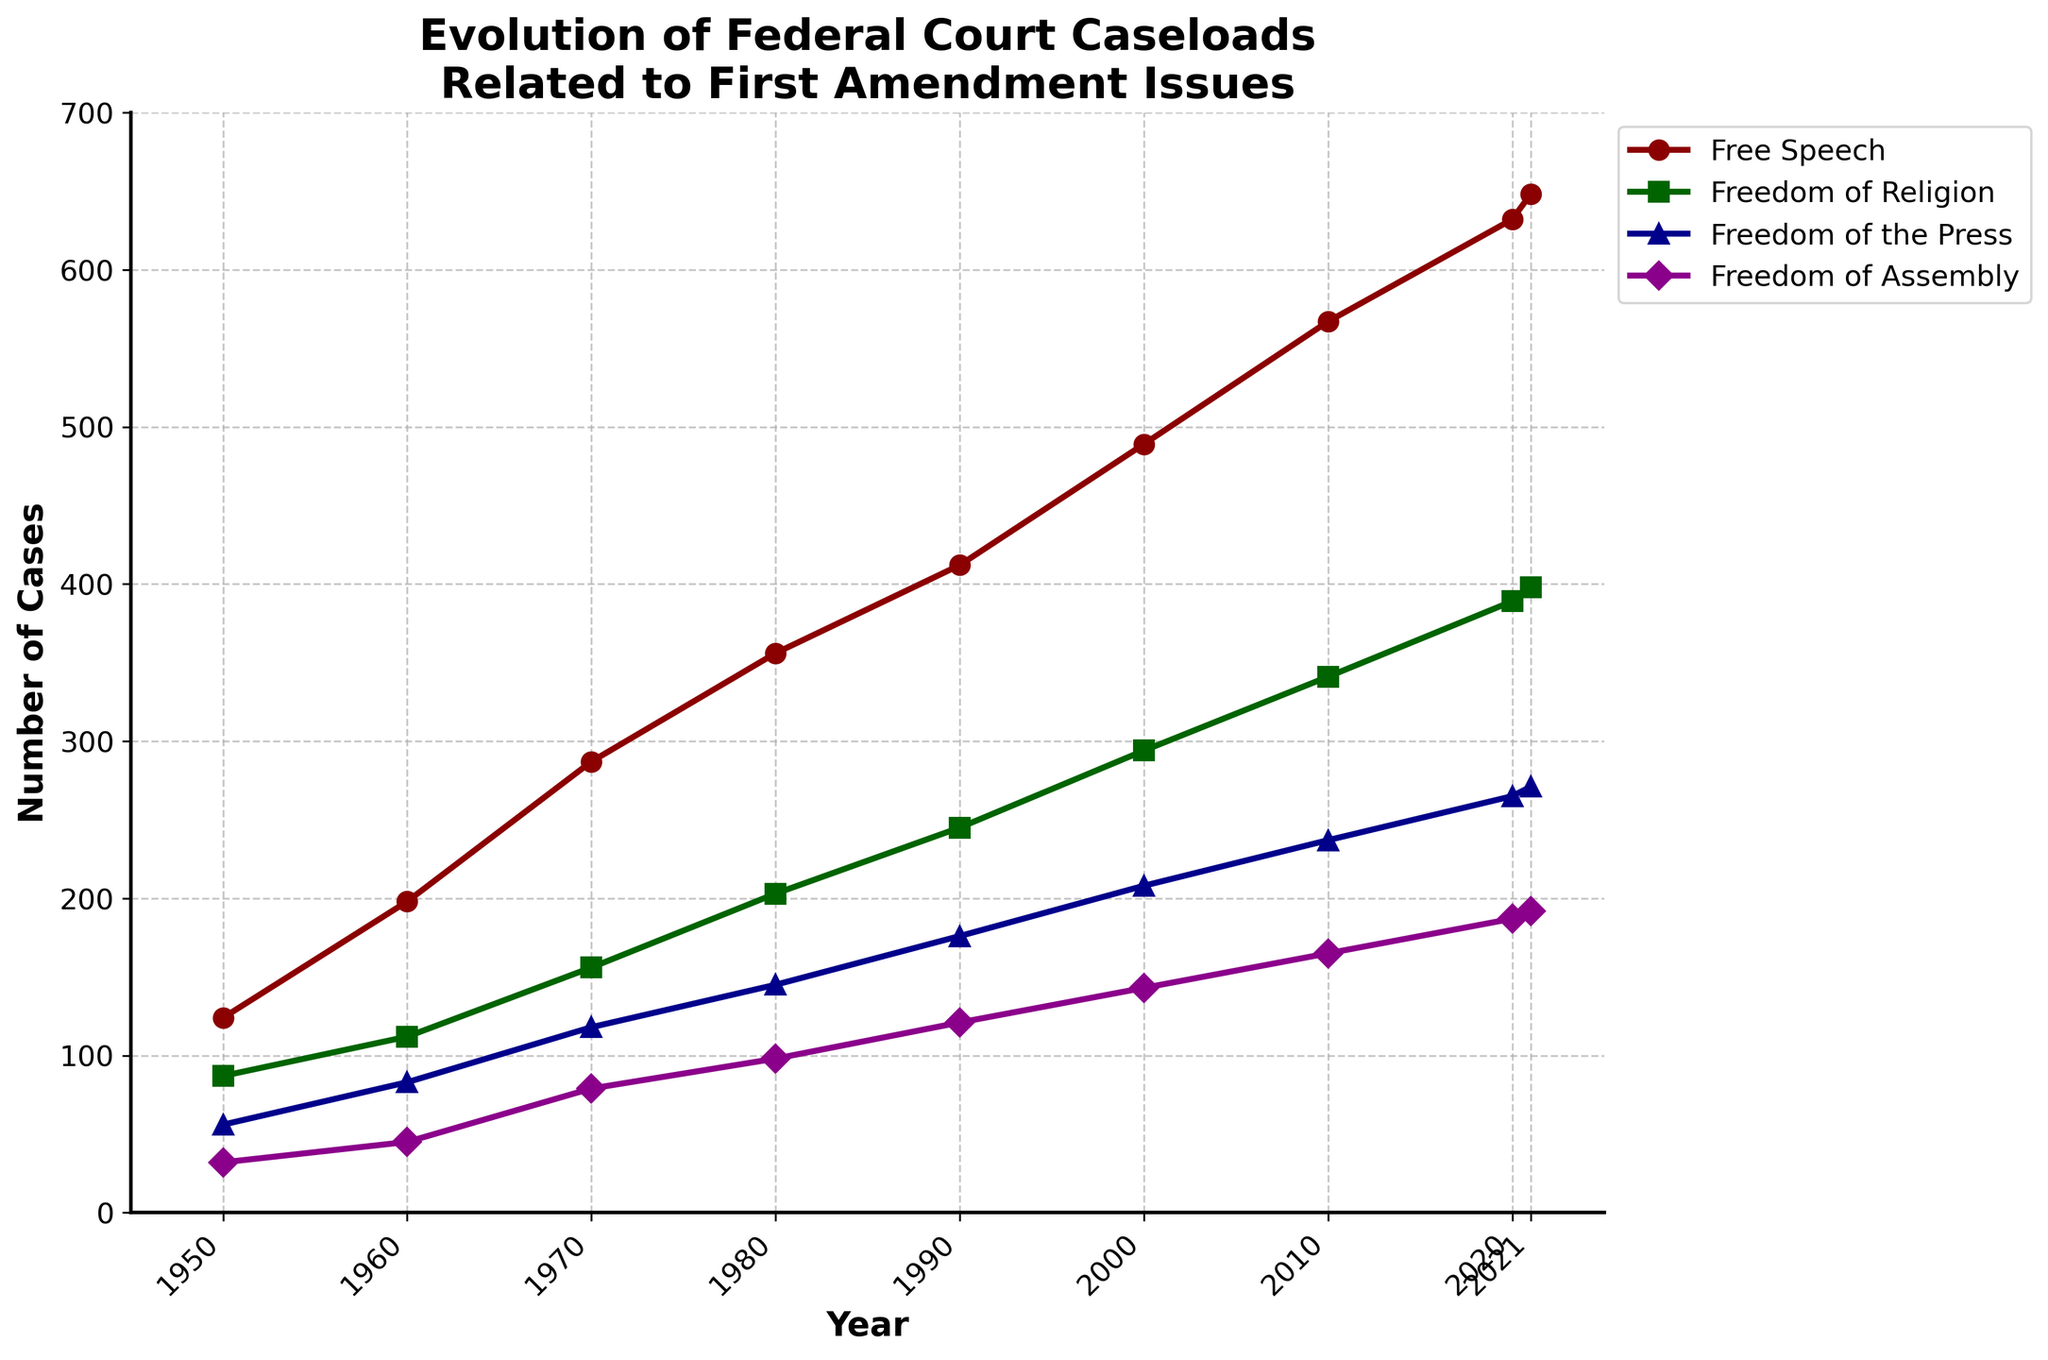1. What is the trend in the number of Free Speech cases from 1950 to 2021? First, observe the line representing Free Speech cases from 1950 to 2021. The line consistently increases, indicating a rising trend in the number of cases over the given years.
Answer: Rising trend 2. By how much did the number of Freedom of the Press cases increase from 1950 to 2021? Check the number of Freedom of the Press cases in 1950 (56) and 2021 (271). Subtract the 1950 value from the 2021 value: 271 - 56 = 215.
Answer: 215 3. Which year had the highest number of Freedom of Religion cases? Identify the peak of the green line representing Freedom of Religion cases. The highest point on the green line is in 2021, with 398 cases.
Answer: 2021 4. Was there a year when Free Speech cases were less than Freedom of the Press cases? Compare the Free Speech and Freedom of the Press lines for every year. The red line for Free Speech is always higher than the blue line for Freedom of the Press.
Answer: No 5. Calculate the average number of Freedom of Assembly cases from 1950 to 2021. Sum the number of Freedom of Assembly cases from 1950 (32), 1960 (45), 1970 (79), 1980 (98), 1990 (121), 2000 (143), 2010 (165), 2020 (187), and 2021 (192). Total: 32 + 45 + 79 + 98 + 121 + 143 + 165 + 187 + 192 = 1062. Divide by 9 (total years): 1062 / 9 = 118.
Answer: 118 6. Compare the growth rates of Free Speech and Freedom of Religion cases from 1950 to 2021. For Free Speech, growth from 1950 (124) to 2021 (648): (648 - 124) / 124 = 4.23 or 423%. For Freedom of Religion, growth from 1950 (87) to 2021 (398): (398 - 87) / 87 = 3.57 or 357%. Free Speech has a higher growth rate.
Answer: Free Speech 7. Which specific right had the smallest increase in case numbers from 1950 to 2021? Calculate the increase for each right: Free Speech: 648 - 124 = 524, Freedom of Religion: 398 - 87 = 311, Freedom of the Press: 271 - 56 = 215, Freedom of Assembly: 192 - 32 = 160. Freedom of Assembly had the smallest increase.
Answer: Freedom of Assembly 8. What is the difference between the number of Free Speech and Freedom of Religion cases in 2020? In 2020, Free Speech had 632 cases and Freedom of Religion had 389 cases. Subtract the latter from the former: 632 - 389 = 243.
Answer: 243 9. Identify the year with the highest total number of First Amendment cases (sum of all rights). Sum up cases for each right for every year. For 2021: 648 (Free Speech) + 398 (Freedom of Religion) + 271 (Freedom of the Press) + 192 (Freedom of Assembly) = 1509. This is the highest among all years.
Answer: 2021 